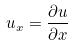Convert formula to latex. <formula><loc_0><loc_0><loc_500><loc_500>u _ { x } = \frac { \partial u } { \partial x }</formula> 